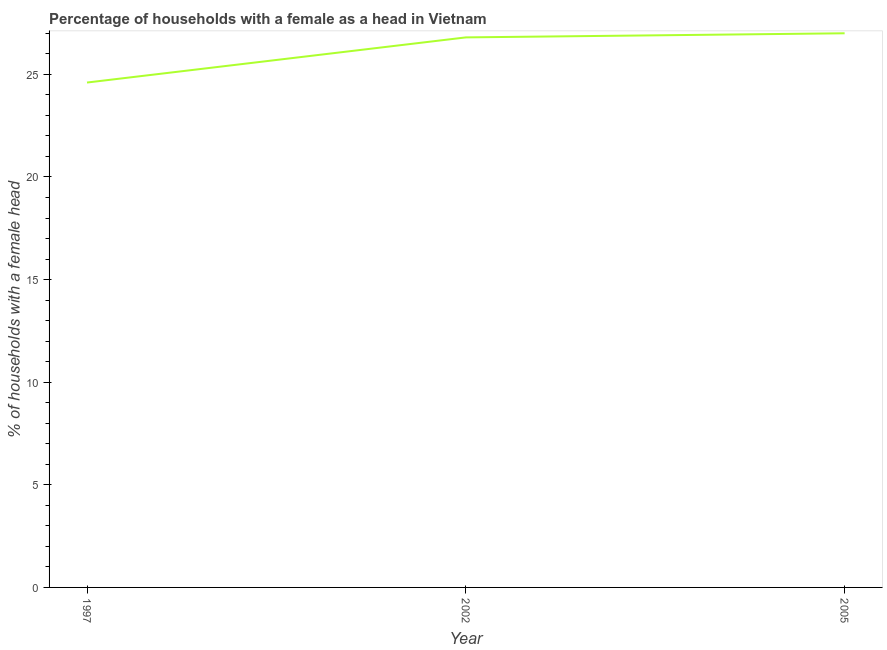What is the number of female supervised households in 2005?
Offer a terse response. 27. Across all years, what is the minimum number of female supervised households?
Provide a short and direct response. 24.6. In which year was the number of female supervised households minimum?
Your answer should be very brief. 1997. What is the sum of the number of female supervised households?
Ensure brevity in your answer.  78.4. What is the difference between the number of female supervised households in 1997 and 2005?
Your response must be concise. -2.4. What is the average number of female supervised households per year?
Your answer should be compact. 26.13. What is the median number of female supervised households?
Offer a terse response. 26.8. In how many years, is the number of female supervised households greater than 6 %?
Your answer should be very brief. 3. Do a majority of the years between 2002 and 2005 (inclusive) have number of female supervised households greater than 12 %?
Ensure brevity in your answer.  Yes. What is the ratio of the number of female supervised households in 2002 to that in 2005?
Make the answer very short. 0.99. What is the difference between the highest and the second highest number of female supervised households?
Give a very brief answer. 0.2. Is the sum of the number of female supervised households in 1997 and 2002 greater than the maximum number of female supervised households across all years?
Your answer should be very brief. Yes. What is the difference between the highest and the lowest number of female supervised households?
Your response must be concise. 2.4. In how many years, is the number of female supervised households greater than the average number of female supervised households taken over all years?
Make the answer very short. 2. How many lines are there?
Give a very brief answer. 1. Does the graph contain any zero values?
Your answer should be very brief. No. What is the title of the graph?
Make the answer very short. Percentage of households with a female as a head in Vietnam. What is the label or title of the Y-axis?
Provide a short and direct response. % of households with a female head. What is the % of households with a female head in 1997?
Provide a succinct answer. 24.6. What is the % of households with a female head in 2002?
Your answer should be very brief. 26.8. What is the difference between the % of households with a female head in 1997 and 2005?
Give a very brief answer. -2.4. What is the ratio of the % of households with a female head in 1997 to that in 2002?
Keep it short and to the point. 0.92. What is the ratio of the % of households with a female head in 1997 to that in 2005?
Your answer should be very brief. 0.91. What is the ratio of the % of households with a female head in 2002 to that in 2005?
Ensure brevity in your answer.  0.99. 